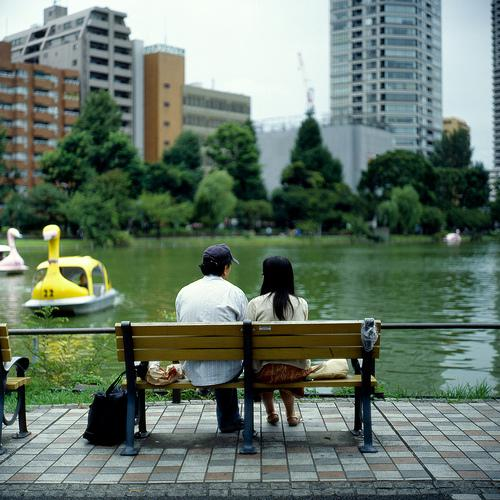Question: what is yellow?
Choices:
A. Banana.
B. Paddle boat.
C. Squash.
D. Pepper.
Answer with the letter. Answer: B Question: where are they sitting?
Choices:
A. Chair.
B. Bleachers.
C. Couch.
D. On a bench.
Answer with the letter. Answer: D Question: who is sitting on the bench?
Choices:
A. Children.
B. Dog.
C. Man and woman.
D. Cat.
Answer with the letter. Answer: C Question: what are they doing?
Choices:
A. Watching the sunset.
B. Watching the ducks.
C. Fishing in the lake.
D. Walking on the beach.
Answer with the letter. Answer: B Question: why is the goose yellow?
Choices:
A. Natural color.
B. That's the color they painted it.
C. It's being lit by yellow light.
D. It is sick.
Answer with the letter. Answer: B Question: when was the photo taken?
Choices:
A. Dawn.
B. Day time.
C. Twilight.
D. Midnight.
Answer with the letter. Answer: B 